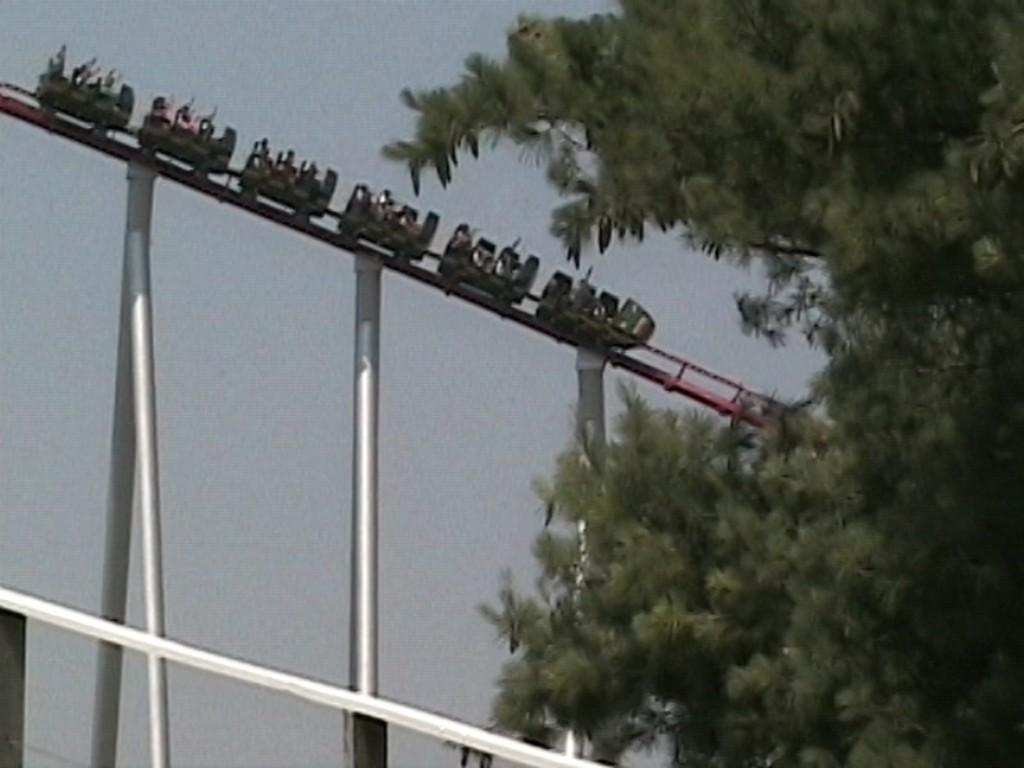What type of tree is in the image? There is a green tree in the image. What other structures can be seen in the image? There are huge metal poles and a roller coaster in the image. Who or what is on the roller coaster? There are people in the roller coaster. What can be seen in the background of the image? The sky is visible in the background of the image. What is the opinion of the tiger about the roller coaster in the image? There is no tiger present in the image, so it is not possible to determine its opinion about the roller coaster. 